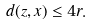<formula> <loc_0><loc_0><loc_500><loc_500>d ( z , x ) \leq 4 r .</formula> 